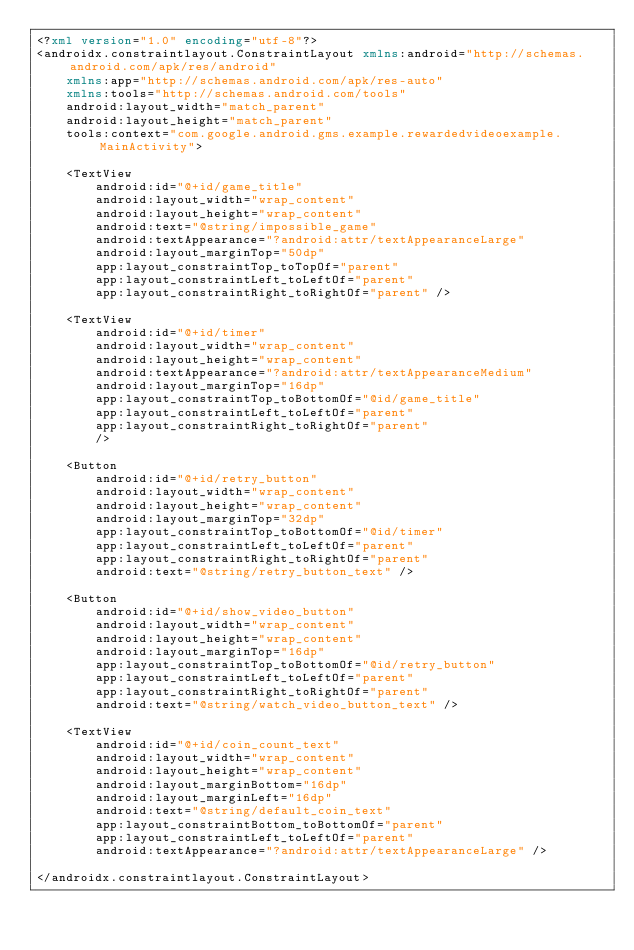Convert code to text. <code><loc_0><loc_0><loc_500><loc_500><_XML_><?xml version="1.0" encoding="utf-8"?>
<androidx.constraintlayout.ConstraintLayout xmlns:android="http://schemas.android.com/apk/res/android"
    xmlns:app="http://schemas.android.com/apk/res-auto"
    xmlns:tools="http://schemas.android.com/tools"
    android:layout_width="match_parent"
    android:layout_height="match_parent"
    tools:context="com.google.android.gms.example.rewardedvideoexample.MainActivity">

    <TextView
        android:id="@+id/game_title"
        android:layout_width="wrap_content"
        android:layout_height="wrap_content"
        android:text="@string/impossible_game"
        android:textAppearance="?android:attr/textAppearanceLarge"
        android:layout_marginTop="50dp"
        app:layout_constraintTop_toTopOf="parent"
        app:layout_constraintLeft_toLeftOf="parent"
        app:layout_constraintRight_toRightOf="parent" />

    <TextView
        android:id="@+id/timer"
        android:layout_width="wrap_content"
        android:layout_height="wrap_content"
        android:textAppearance="?android:attr/textAppearanceMedium"
        android:layout_marginTop="16dp"
        app:layout_constraintTop_toBottomOf="@id/game_title"
        app:layout_constraintLeft_toLeftOf="parent"
        app:layout_constraintRight_toRightOf="parent"
        />

    <Button
        android:id="@+id/retry_button"
        android:layout_width="wrap_content"
        android:layout_height="wrap_content"
        android:layout_marginTop="32dp"
        app:layout_constraintTop_toBottomOf="@id/timer"
        app:layout_constraintLeft_toLeftOf="parent"
        app:layout_constraintRight_toRightOf="parent"
        android:text="@string/retry_button_text" />

    <Button
        android:id="@+id/show_video_button"
        android:layout_width="wrap_content"
        android:layout_height="wrap_content"
        android:layout_marginTop="16dp"
        app:layout_constraintTop_toBottomOf="@id/retry_button"
        app:layout_constraintLeft_toLeftOf="parent"
        app:layout_constraintRight_toRightOf="parent"
        android:text="@string/watch_video_button_text" />

    <TextView
        android:id="@+id/coin_count_text"
        android:layout_width="wrap_content"
        android:layout_height="wrap_content"
        android:layout_marginBottom="16dp"
        android:layout_marginLeft="16dp"
        android:text="@string/default_coin_text"
        app:layout_constraintBottom_toBottomOf="parent"
        app:layout_constraintLeft_toLeftOf="parent"
        android:textAppearance="?android:attr/textAppearanceLarge" />

</androidx.constraintlayout.ConstraintLayout>
</code> 